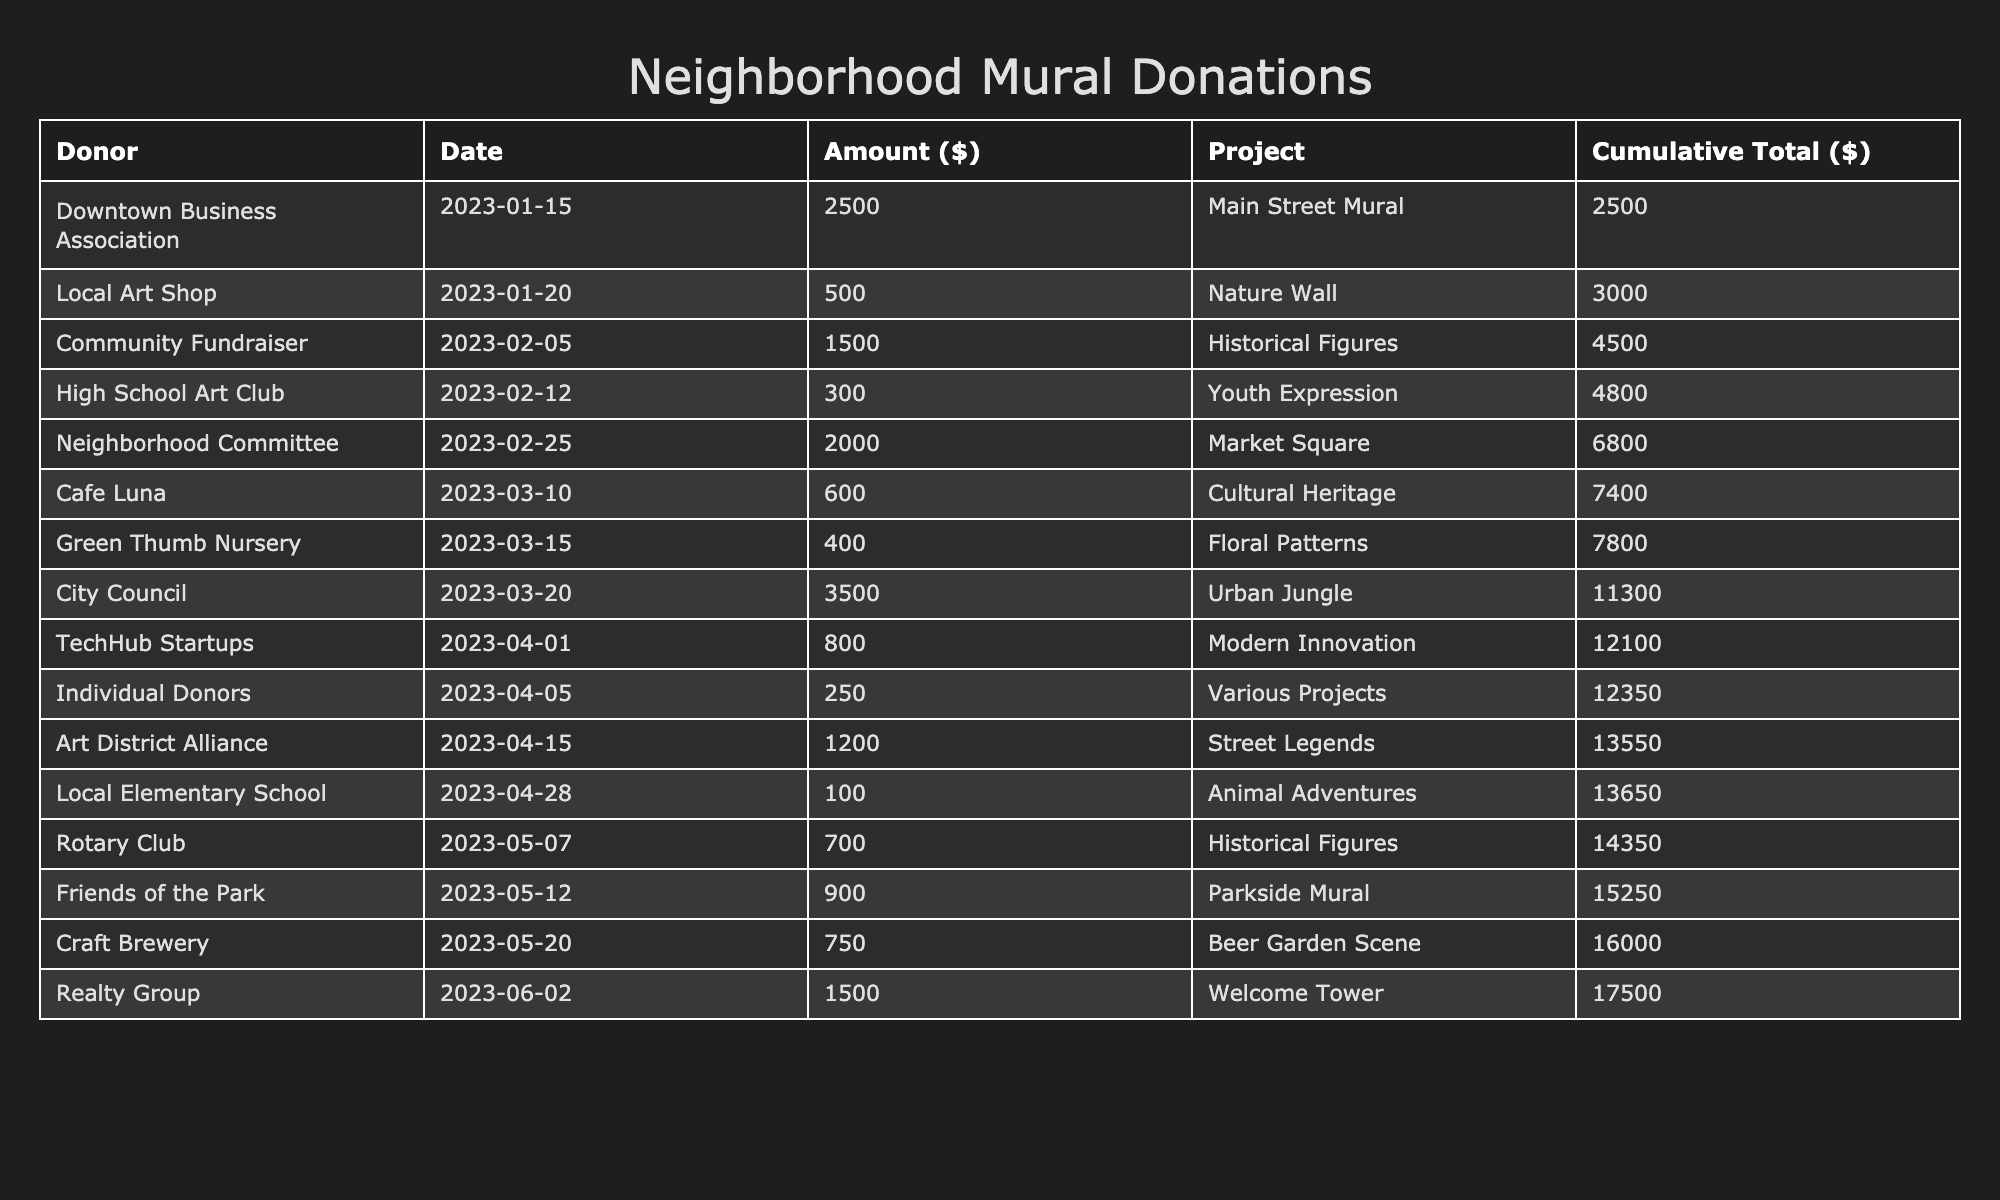What is the total amount donated for the "Main Street Mural"? The amount donated for the "Main Street Mural" is directly listed in the table under the Amount column. The specific entry shows a donation of 2500 dollars.
Answer: 2500 Which donor contributed to the "Historical Figures" project? From the table, the entry for the "Historical Figures" project displays two donors: "Community Fundraiser" and "Rotary Club," with amounts of 1500 and 700 dollars respectively.
Answer: Community Fundraiser and Rotary Club What was the cumulative total after the "Cultural Heritage" donation? We need to look at all donations made up to and including the "Cultural Heritage" donation, which is 600 dollars, and add the previous cumulative total to it. The previous cumulative total before this donation is 10000, then it becomes 10600 dollars after including this donation.
Answer: 10600 How many donations were made in March? By checking the Donation Date column, we see that there are four donations listed for March (Cafe Luna, Green Thumb Nursery, City Council, and Friends of the Park). Thus, the total number of donations in March is 4.
Answer: 4 Is the "High School Art Club" the only donor for the "Youth Expression" project? Looking at the table, we see that the "Youth Expression" project has only one entry indicating the "High School Art Club" and no other donors listed, confirming it is the only donor for this project.
Answer: Yes What is the average donation amount from the "Individual Donors"? The amount donated by "Individual Donors" is 250 dollars for various projects. Since there’s only one donation from this group, the average is simply 250 dollars (total amount divided by the number of donations, which is one).
Answer: 250 What was the total amount funded for projects related to historical themes? The related projects are "Historical Figures" (1500 + 700) and "Street Legends" (1200). Adding these amounts gives a total of 3400 (1500 + 700 + 1200).
Answer: 3400 What is the largest individual donation mentioned in the table? Examining the Amount column, we identify that the largest single donation is from "City Council," which is 3500 dollars for the "Urban Jungle" project.
Answer: 3500 How much was contributed by the "Downtown Business Association" relative to total donations? The "Downtown Business Association" contributed 2500 dollars. Summing all donations in the table equals 17000 dollars. To find out the relative contribution, we take (2500 / 17000) * 100, resulting in approximately 14.71%.
Answer: 14.71% 